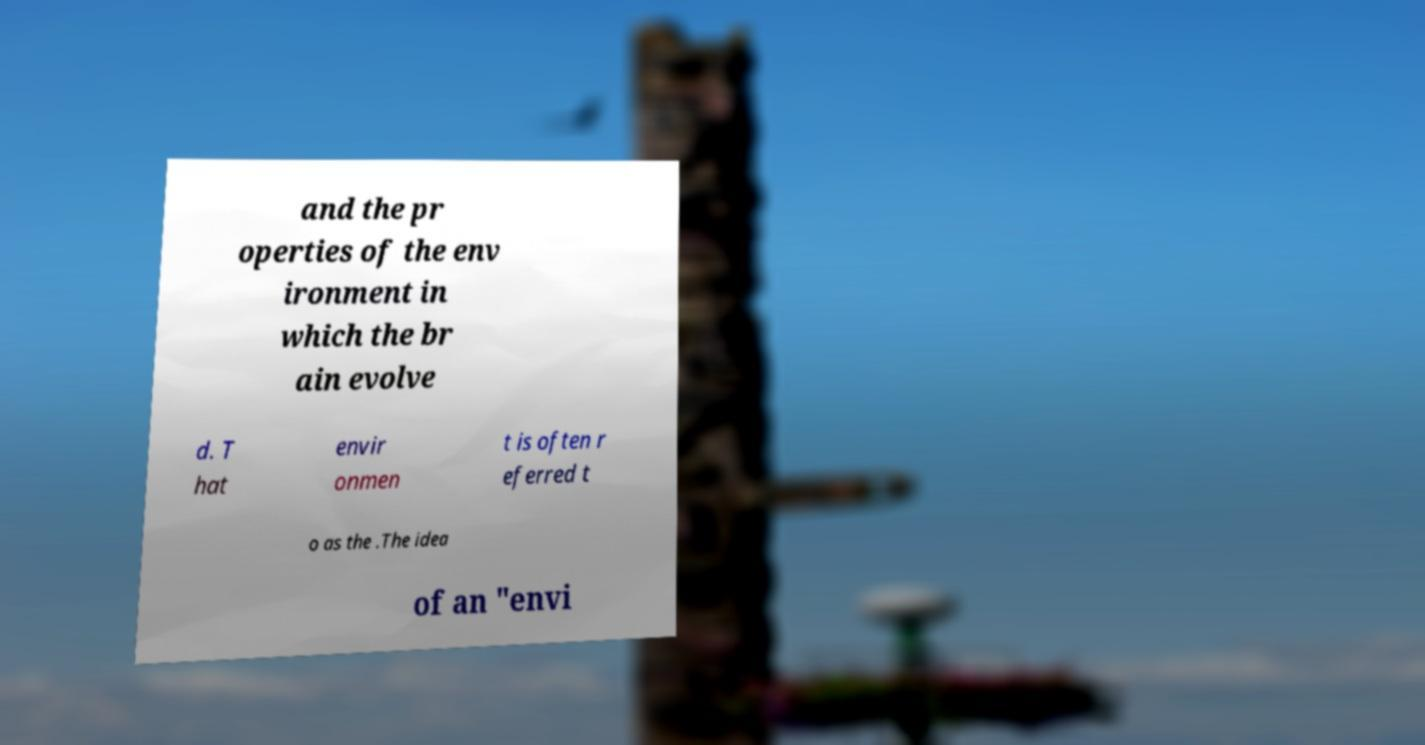Please identify and transcribe the text found in this image. and the pr operties of the env ironment in which the br ain evolve d. T hat envir onmen t is often r eferred t o as the .The idea of an "envi 